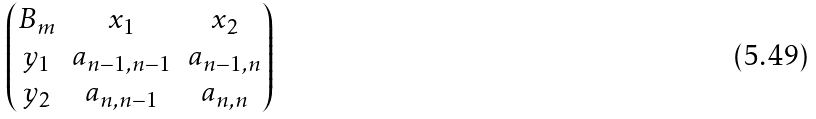Convert formula to latex. <formula><loc_0><loc_0><loc_500><loc_500>\begin{pmatrix} B _ { m } & x _ { 1 } & x _ { 2 } \\ y _ { 1 } & a _ { n - 1 , n - 1 } & a _ { n - 1 , n } \\ y _ { 2 } & a _ { n , n - 1 } & a _ { n , n } \\ \end{pmatrix}</formula> 